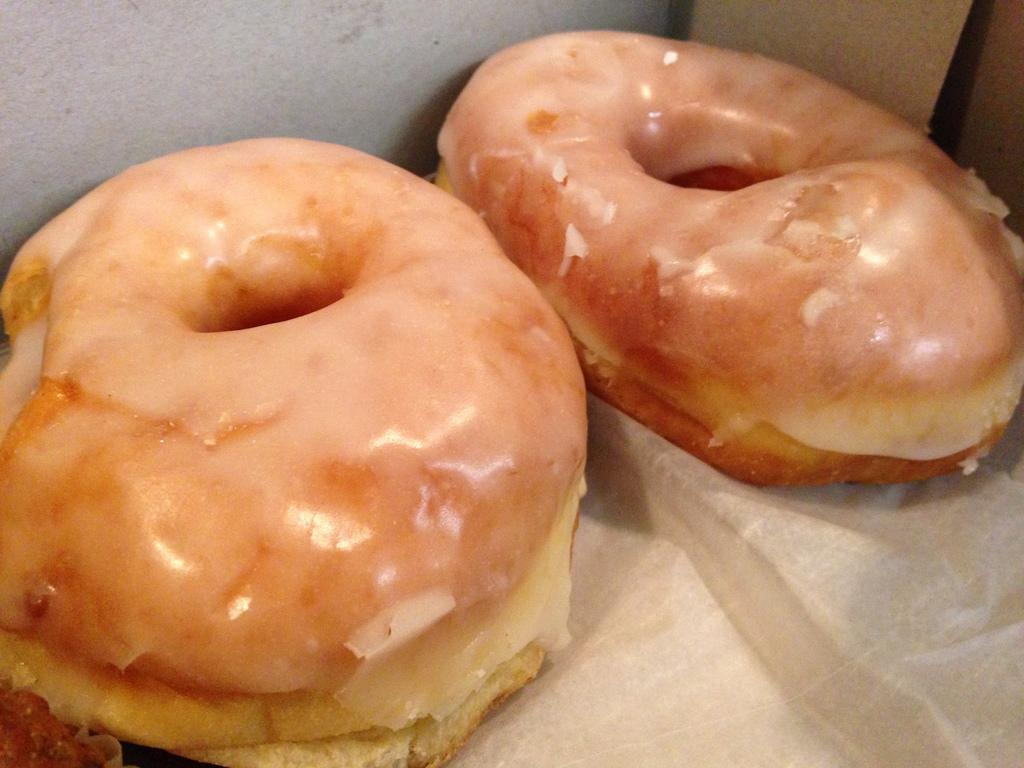What type of food is visible in the image? There are two doughnuts in the image. How are the doughnuts being stored or transported? The doughnuts are packed in a box. Is there any additional material present in the box? Yes, there is a paper at the bottom of the box. Can you see any mice, dog, or kitty interacting with the doughnuts in the image? No, there are no mice, dog, or kitty present in the image. 